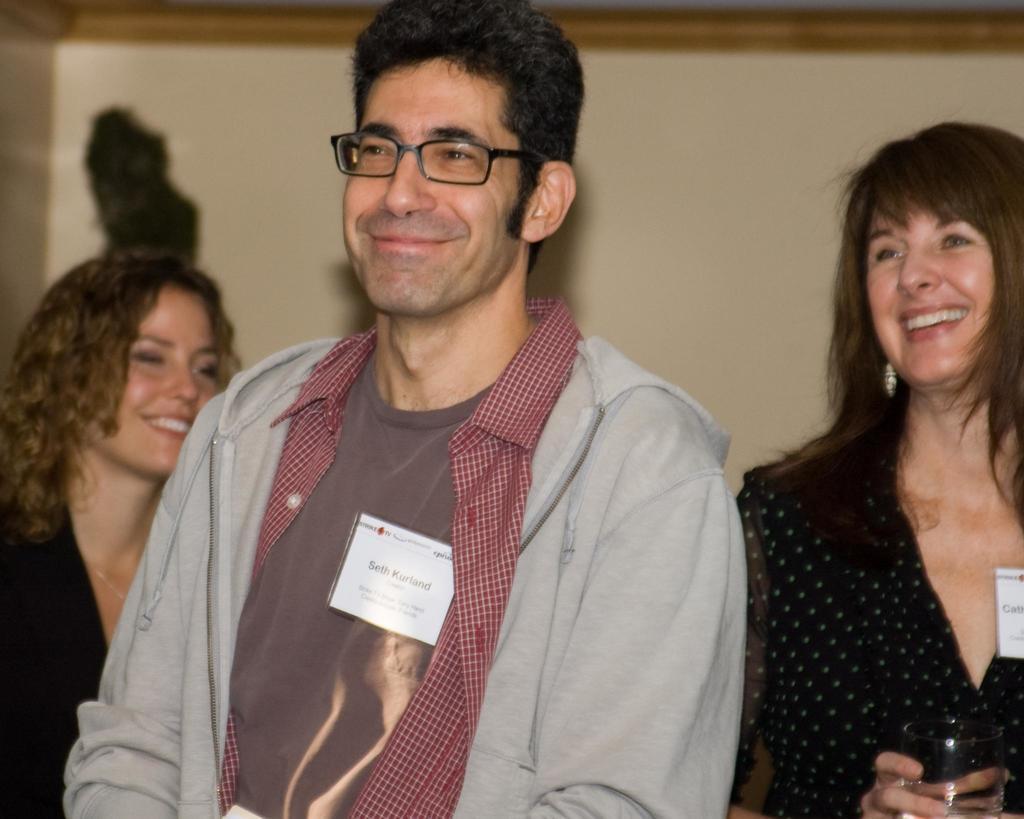How would you summarize this image in a sentence or two? In this image there is a man with spectacles and tag is smiling, and in the background there are two persons smiling , a person holding a glass. 